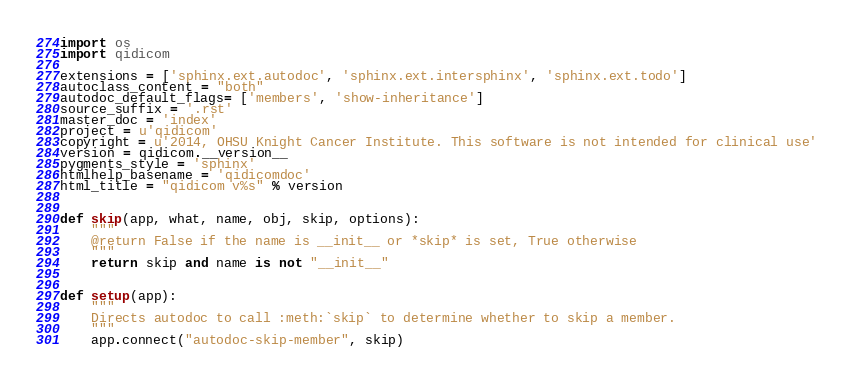<code> <loc_0><loc_0><loc_500><loc_500><_Python_>import os
import qidicom

extensions = ['sphinx.ext.autodoc', 'sphinx.ext.intersphinx', 'sphinx.ext.todo']
autoclass_content = "both"
autodoc_default_flags= ['members', 'show-inheritance']
source_suffix = '.rst'
master_doc = 'index'
project = u'qidicom'
copyright = u'2014, OHSU Knight Cancer Institute. This software is not intended for clinical use'
version = qidicom.__version__
pygments_style = 'sphinx'
htmlhelp_basename = 'qidicomdoc'
html_title = "qidicom v%s" % version


def skip(app, what, name, obj, skip, options):
    """
    @return False if the name is __init__ or *skip* is set, True otherwise
    """
    return skip and name is not "__init__"


def setup(app):
    """
    Directs autodoc to call :meth:`skip` to determine whether to skip a member.
    """
    app.connect("autodoc-skip-member", skip)
</code> 